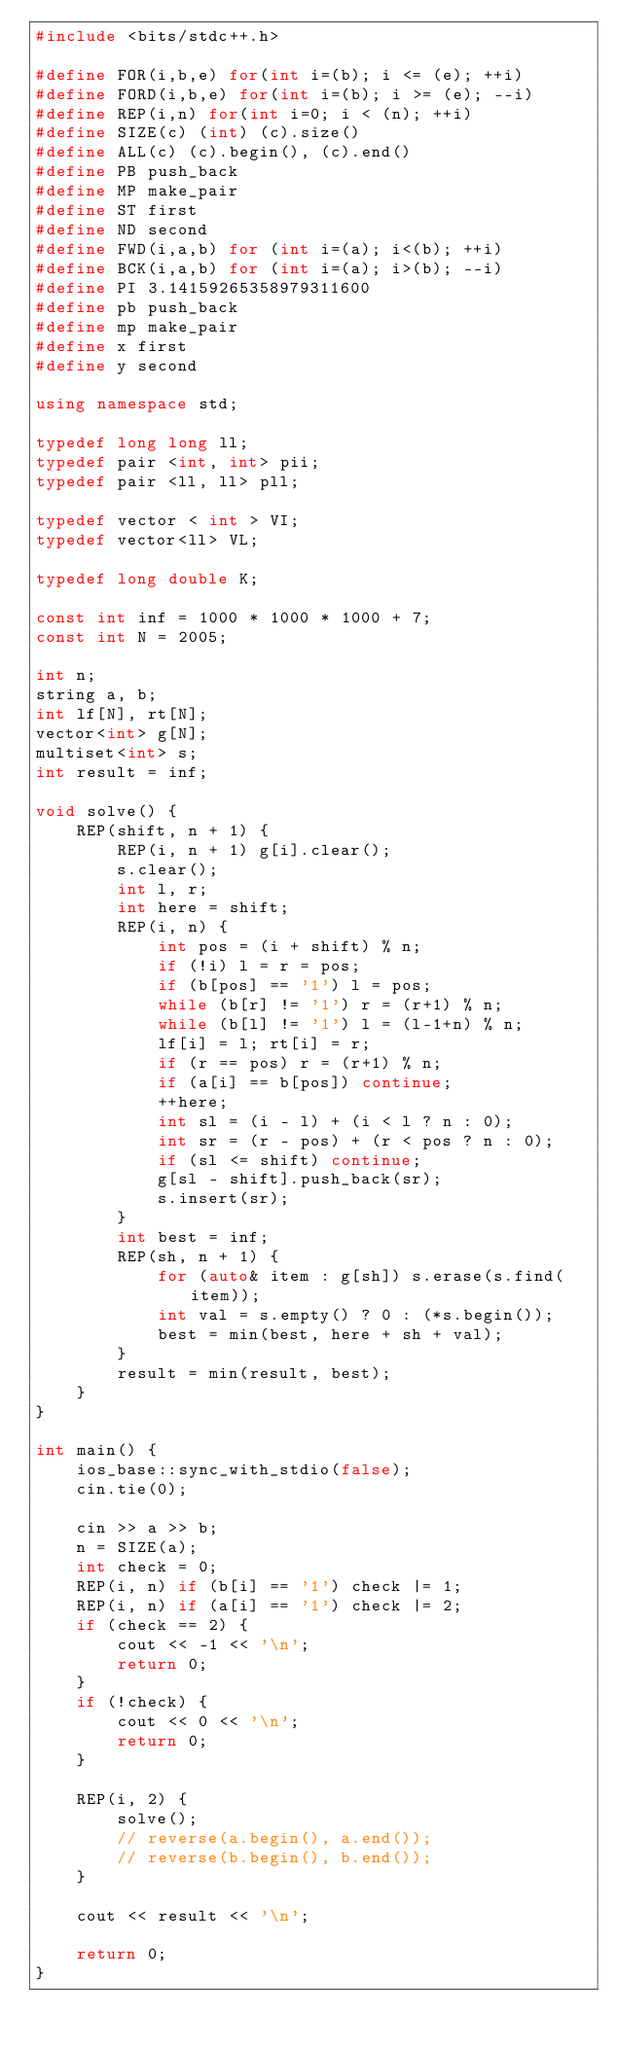Convert code to text. <code><loc_0><loc_0><loc_500><loc_500><_C++_>#include <bits/stdc++.h>

#define FOR(i,b,e) for(int i=(b); i <= (e); ++i)
#define FORD(i,b,e) for(int i=(b); i >= (e); --i)
#define REP(i,n) for(int i=0; i < (n); ++i)
#define SIZE(c) (int) (c).size()
#define ALL(c) (c).begin(), (c).end()
#define PB push_back
#define MP make_pair
#define ST first
#define ND second
#define FWD(i,a,b) for (int i=(a); i<(b); ++i)
#define BCK(i,a,b) for (int i=(a); i>(b); --i)
#define PI 3.14159265358979311600
#define pb push_back
#define mp make_pair
#define x first
#define y second

using namespace std;

typedef long long ll;
typedef pair <int, int> pii;
typedef pair <ll, ll> pll;

typedef vector < int > VI;
typedef vector<ll> VL;

typedef long double K;

const int inf = 1000 * 1000 * 1000 + 7;
const int N = 2005;

int n;
string a, b;
int lf[N], rt[N];
vector<int> g[N];
multiset<int> s;
int result = inf;

void solve() {
	REP(shift, n + 1) {
		REP(i, n + 1) g[i].clear();
		s.clear();
		int l, r;
		int here = shift;
		REP(i, n) {
			int pos = (i + shift) % n;
			if (!i) l = r = pos;
			if (b[pos] == '1') l = pos;
			while (b[r] != '1') r = (r+1) % n;
			while (b[l] != '1') l = (l-1+n) % n;
			lf[i] = l; rt[i] = r;
			if (r == pos) r = (r+1) % n;
			if (a[i] == b[pos]) continue;
			++here;
			int sl = (i - l) + (i < l ? n : 0);
			int sr = (r - pos) + (r < pos ? n : 0);
			if (sl <= shift) continue;
			g[sl - shift].push_back(sr);
			s.insert(sr);
		}
		int best = inf;
		REP(sh, n + 1) {
			for (auto& item : g[sh]) s.erase(s.find(item));
			int val = s.empty() ? 0 : (*s.begin());
			best = min(best, here + sh + val);
		}
		result = min(result, best);
	}
}

int main() {
	ios_base::sync_with_stdio(false);
	cin.tie(0);

	cin >> a >> b;
	n = SIZE(a);
	int check = 0;
	REP(i, n) if (b[i] == '1') check |= 1;
	REP(i, n) if (a[i] == '1') check |= 2;
	if (check == 2) {
		cout << -1 << '\n';
		return 0;
	}
	if (!check) {
		cout << 0 << '\n';
		return 0;
	}

	REP(i, 2) {
		solve();
		// reverse(a.begin(), a.end());
		// reverse(b.begin(), b.end());
	}

	cout << result << '\n';

	return 0;
}</code> 